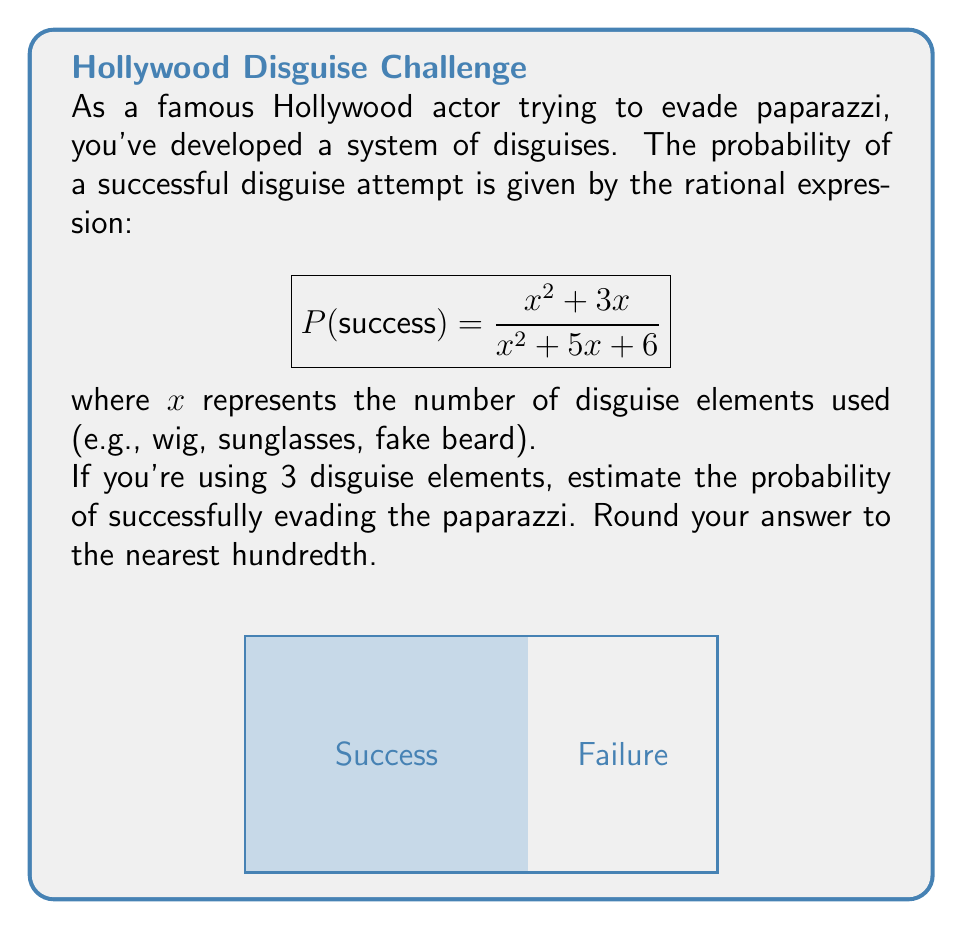Could you help me with this problem? Let's approach this step-by-step:

1) We're given the probability function:
   $$P(success) = \frac{x^2 + 3x}{x^2 + 5x + 6}$$

2) We need to evaluate this function for $x = 3$ (3 disguise elements):
   $$P(success) = \frac{3^2 + 3(3)}{3^2 + 5(3) + 6}$$

3) Let's simplify the numerator:
   $3^2 = 9$
   $3(3) = 9$
   $9 + 9 = 18$

4) Now the denominator:
   $3^2 = 9$
   $5(3) = 15$
   $9 + 15 + 6 = 30$

5) Our fraction is now:
   $$P(success) = \frac{18}{30}$$

6) To simplify this fraction, we can divide both numerator and denominator by their greatest common divisor, which is 6:
   $$P(success) = \frac{18 \div 6}{30 \div 6} = \frac{3}{5} = 0.6$$

7) Rounding to the nearest hundredth gives us 0.60 or 60%.
Answer: 0.60 or 60% 